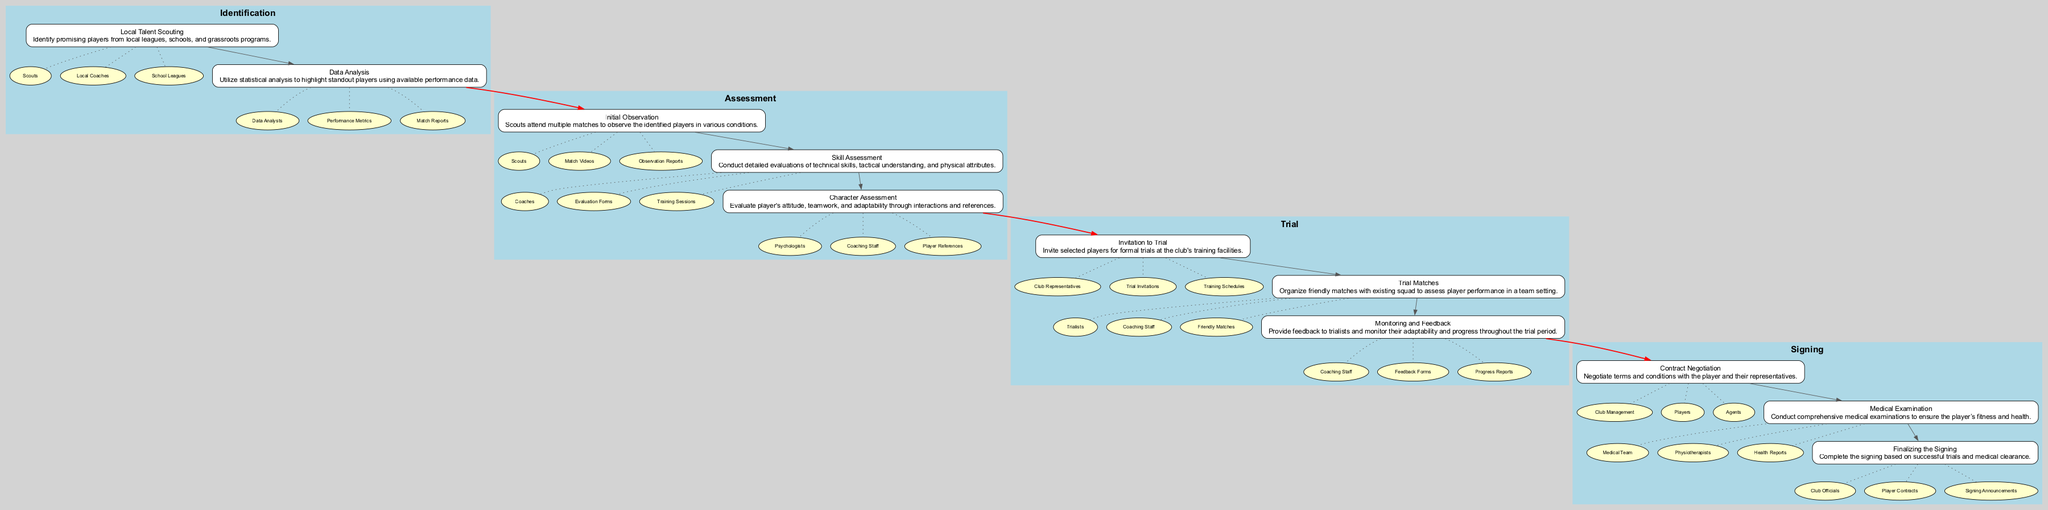What is the first step in the Identification phase? The first step in the Identification phase is "Local Talent Scouting," which focuses on identifying promising players from local leagues, schools, and grassroots programs.
Answer: Local Talent Scouting How many steps are in the Assessment phase? The Assessment phase consists of three steps, which are Initial Observation, Skill Assessment, and Character Assessment.
Answer: 3 What type of entities are involved in 'Skill Assessment'? The entities involved in 'Skill Assessment' are Coaches, Evaluation Forms, and Training Sessions.
Answer: Coaches, Evaluation Forms, Training Sessions Which phase comes after the Trial phase? The phase that comes after the Trial phase is the Signing phase. This follows the structure where the Trial phase is immediately followed by Signing, as indicated by the edges connecting these phases.
Answer: Signing Who evaluates the player's attitude in the Assessment phase? In the Assessment phase, the player's attitude is evaluated by Psychologists, who interact with the player to assess their character and teamwork.
Answer: Psychologists What is the primary purpose of 'Monitoring and Feedback' in the Trial phase? The primary purpose of 'Monitoring and Feedback' is to provide feedback to trialists and monitor their adaptability and progress throughout the trial period.
Answer: Provide feedback and monitor adaptability How many total phases are there in the Clinical Pathway? There are four total phases in the Clinical Pathway: Identification, Assessment, Trial, and Signing.
Answer: 4 What is connected to 'Trial Matches' in the Trial phase? 'Trial Matches' is connected to the entities Trialists, Coaching Staff, and Friendly Matches, indicating the resources and participants involved in this step.
Answer: Trialists, Coaching Staff, Friendly Matches What step precedes 'Contract Negotiation' in the Signing phase? The step that precedes 'Contract Negotiation' in the Signing phase is 'Medical Examination,' which must be completed before negotiating contract terms.
Answer: Medical Examination 